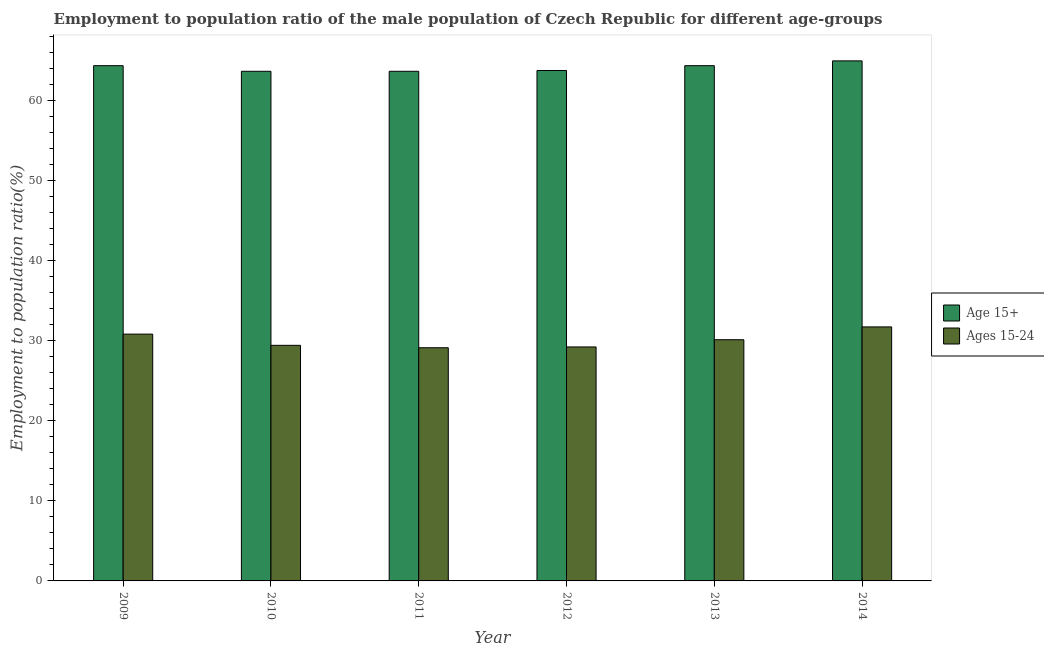How many different coloured bars are there?
Keep it short and to the point. 2. How many groups of bars are there?
Keep it short and to the point. 6. Are the number of bars per tick equal to the number of legend labels?
Ensure brevity in your answer.  Yes. How many bars are there on the 6th tick from the left?
Ensure brevity in your answer.  2. How many bars are there on the 1st tick from the right?
Provide a succinct answer. 2. In how many cases, is the number of bars for a given year not equal to the number of legend labels?
Give a very brief answer. 0. What is the employment to population ratio(age 15-24) in 2009?
Make the answer very short. 30.8. Across all years, what is the maximum employment to population ratio(age 15+)?
Your answer should be compact. 64.9. Across all years, what is the minimum employment to population ratio(age 15+)?
Your answer should be compact. 63.6. What is the total employment to population ratio(age 15-24) in the graph?
Ensure brevity in your answer.  180.3. What is the difference between the employment to population ratio(age 15-24) in 2012 and that in 2013?
Ensure brevity in your answer.  -0.9. What is the difference between the employment to population ratio(age 15-24) in 2009 and the employment to population ratio(age 15+) in 2013?
Ensure brevity in your answer.  0.7. What is the average employment to population ratio(age 15+) per year?
Your answer should be compact. 64.07. What is the ratio of the employment to population ratio(age 15-24) in 2010 to that in 2013?
Provide a succinct answer. 0.98. What is the difference between the highest and the second highest employment to population ratio(age 15-24)?
Make the answer very short. 0.9. What is the difference between the highest and the lowest employment to population ratio(age 15+)?
Your answer should be compact. 1.3. What does the 2nd bar from the left in 2014 represents?
Offer a terse response. Ages 15-24. What does the 2nd bar from the right in 2010 represents?
Provide a succinct answer. Age 15+. How many bars are there?
Keep it short and to the point. 12. Are all the bars in the graph horizontal?
Make the answer very short. No. How many years are there in the graph?
Make the answer very short. 6. Does the graph contain grids?
Make the answer very short. No. Where does the legend appear in the graph?
Give a very brief answer. Center right. How many legend labels are there?
Your answer should be compact. 2. How are the legend labels stacked?
Your response must be concise. Vertical. What is the title of the graph?
Provide a succinct answer. Employment to population ratio of the male population of Czech Republic for different age-groups. Does "Old" appear as one of the legend labels in the graph?
Provide a short and direct response. No. What is the label or title of the X-axis?
Your answer should be very brief. Year. What is the Employment to population ratio(%) of Age 15+ in 2009?
Your response must be concise. 64.3. What is the Employment to population ratio(%) of Ages 15-24 in 2009?
Make the answer very short. 30.8. What is the Employment to population ratio(%) in Age 15+ in 2010?
Your answer should be very brief. 63.6. What is the Employment to population ratio(%) of Ages 15-24 in 2010?
Provide a succinct answer. 29.4. What is the Employment to population ratio(%) of Age 15+ in 2011?
Give a very brief answer. 63.6. What is the Employment to population ratio(%) in Ages 15-24 in 2011?
Your answer should be very brief. 29.1. What is the Employment to population ratio(%) of Age 15+ in 2012?
Keep it short and to the point. 63.7. What is the Employment to population ratio(%) of Ages 15-24 in 2012?
Offer a terse response. 29.2. What is the Employment to population ratio(%) in Age 15+ in 2013?
Make the answer very short. 64.3. What is the Employment to population ratio(%) in Ages 15-24 in 2013?
Ensure brevity in your answer.  30.1. What is the Employment to population ratio(%) in Age 15+ in 2014?
Your response must be concise. 64.9. What is the Employment to population ratio(%) of Ages 15-24 in 2014?
Ensure brevity in your answer.  31.7. Across all years, what is the maximum Employment to population ratio(%) of Age 15+?
Provide a short and direct response. 64.9. Across all years, what is the maximum Employment to population ratio(%) of Ages 15-24?
Ensure brevity in your answer.  31.7. Across all years, what is the minimum Employment to population ratio(%) of Age 15+?
Ensure brevity in your answer.  63.6. Across all years, what is the minimum Employment to population ratio(%) of Ages 15-24?
Provide a short and direct response. 29.1. What is the total Employment to population ratio(%) of Age 15+ in the graph?
Offer a terse response. 384.4. What is the total Employment to population ratio(%) in Ages 15-24 in the graph?
Give a very brief answer. 180.3. What is the difference between the Employment to population ratio(%) in Age 15+ in 2009 and that in 2011?
Your answer should be very brief. 0.7. What is the difference between the Employment to population ratio(%) of Ages 15-24 in 2009 and that in 2011?
Keep it short and to the point. 1.7. What is the difference between the Employment to population ratio(%) in Age 15+ in 2009 and that in 2013?
Offer a terse response. 0. What is the difference between the Employment to population ratio(%) in Age 15+ in 2010 and that in 2011?
Give a very brief answer. 0. What is the difference between the Employment to population ratio(%) in Age 15+ in 2010 and that in 2012?
Provide a short and direct response. -0.1. What is the difference between the Employment to population ratio(%) in Ages 15-24 in 2010 and that in 2012?
Provide a short and direct response. 0.2. What is the difference between the Employment to population ratio(%) of Age 15+ in 2010 and that in 2013?
Ensure brevity in your answer.  -0.7. What is the difference between the Employment to population ratio(%) of Ages 15-24 in 2010 and that in 2013?
Make the answer very short. -0.7. What is the difference between the Employment to population ratio(%) of Age 15+ in 2011 and that in 2012?
Your answer should be very brief. -0.1. What is the difference between the Employment to population ratio(%) in Ages 15-24 in 2011 and that in 2013?
Keep it short and to the point. -1. What is the difference between the Employment to population ratio(%) in Age 15+ in 2012 and that in 2014?
Provide a short and direct response. -1.2. What is the difference between the Employment to population ratio(%) in Ages 15-24 in 2012 and that in 2014?
Keep it short and to the point. -2.5. What is the difference between the Employment to population ratio(%) in Age 15+ in 2009 and the Employment to population ratio(%) in Ages 15-24 in 2010?
Provide a short and direct response. 34.9. What is the difference between the Employment to population ratio(%) in Age 15+ in 2009 and the Employment to population ratio(%) in Ages 15-24 in 2011?
Offer a very short reply. 35.2. What is the difference between the Employment to population ratio(%) in Age 15+ in 2009 and the Employment to population ratio(%) in Ages 15-24 in 2012?
Keep it short and to the point. 35.1. What is the difference between the Employment to population ratio(%) in Age 15+ in 2009 and the Employment to population ratio(%) in Ages 15-24 in 2013?
Provide a succinct answer. 34.2. What is the difference between the Employment to population ratio(%) in Age 15+ in 2009 and the Employment to population ratio(%) in Ages 15-24 in 2014?
Give a very brief answer. 32.6. What is the difference between the Employment to population ratio(%) in Age 15+ in 2010 and the Employment to population ratio(%) in Ages 15-24 in 2011?
Give a very brief answer. 34.5. What is the difference between the Employment to population ratio(%) of Age 15+ in 2010 and the Employment to population ratio(%) of Ages 15-24 in 2012?
Offer a terse response. 34.4. What is the difference between the Employment to population ratio(%) of Age 15+ in 2010 and the Employment to population ratio(%) of Ages 15-24 in 2013?
Offer a terse response. 33.5. What is the difference between the Employment to population ratio(%) of Age 15+ in 2010 and the Employment to population ratio(%) of Ages 15-24 in 2014?
Provide a short and direct response. 31.9. What is the difference between the Employment to population ratio(%) in Age 15+ in 2011 and the Employment to population ratio(%) in Ages 15-24 in 2012?
Give a very brief answer. 34.4. What is the difference between the Employment to population ratio(%) of Age 15+ in 2011 and the Employment to population ratio(%) of Ages 15-24 in 2013?
Give a very brief answer. 33.5. What is the difference between the Employment to population ratio(%) of Age 15+ in 2011 and the Employment to population ratio(%) of Ages 15-24 in 2014?
Offer a very short reply. 31.9. What is the difference between the Employment to population ratio(%) in Age 15+ in 2012 and the Employment to population ratio(%) in Ages 15-24 in 2013?
Provide a succinct answer. 33.6. What is the difference between the Employment to population ratio(%) in Age 15+ in 2013 and the Employment to population ratio(%) in Ages 15-24 in 2014?
Offer a very short reply. 32.6. What is the average Employment to population ratio(%) in Age 15+ per year?
Make the answer very short. 64.07. What is the average Employment to population ratio(%) in Ages 15-24 per year?
Ensure brevity in your answer.  30.05. In the year 2009, what is the difference between the Employment to population ratio(%) of Age 15+ and Employment to population ratio(%) of Ages 15-24?
Give a very brief answer. 33.5. In the year 2010, what is the difference between the Employment to population ratio(%) in Age 15+ and Employment to population ratio(%) in Ages 15-24?
Keep it short and to the point. 34.2. In the year 2011, what is the difference between the Employment to population ratio(%) of Age 15+ and Employment to population ratio(%) of Ages 15-24?
Offer a terse response. 34.5. In the year 2012, what is the difference between the Employment to population ratio(%) in Age 15+ and Employment to population ratio(%) in Ages 15-24?
Your response must be concise. 34.5. In the year 2013, what is the difference between the Employment to population ratio(%) of Age 15+ and Employment to population ratio(%) of Ages 15-24?
Give a very brief answer. 34.2. In the year 2014, what is the difference between the Employment to population ratio(%) in Age 15+ and Employment to population ratio(%) in Ages 15-24?
Your response must be concise. 33.2. What is the ratio of the Employment to population ratio(%) in Ages 15-24 in 2009 to that in 2010?
Provide a succinct answer. 1.05. What is the ratio of the Employment to population ratio(%) in Ages 15-24 in 2009 to that in 2011?
Your answer should be compact. 1.06. What is the ratio of the Employment to population ratio(%) of Age 15+ in 2009 to that in 2012?
Give a very brief answer. 1.01. What is the ratio of the Employment to population ratio(%) of Ages 15-24 in 2009 to that in 2012?
Your answer should be very brief. 1.05. What is the ratio of the Employment to population ratio(%) of Ages 15-24 in 2009 to that in 2013?
Your answer should be very brief. 1.02. What is the ratio of the Employment to population ratio(%) in Age 15+ in 2009 to that in 2014?
Provide a succinct answer. 0.99. What is the ratio of the Employment to population ratio(%) in Ages 15-24 in 2009 to that in 2014?
Your answer should be compact. 0.97. What is the ratio of the Employment to population ratio(%) in Age 15+ in 2010 to that in 2011?
Make the answer very short. 1. What is the ratio of the Employment to population ratio(%) of Ages 15-24 in 2010 to that in 2011?
Ensure brevity in your answer.  1.01. What is the ratio of the Employment to population ratio(%) of Ages 15-24 in 2010 to that in 2012?
Give a very brief answer. 1.01. What is the ratio of the Employment to population ratio(%) of Age 15+ in 2010 to that in 2013?
Provide a succinct answer. 0.99. What is the ratio of the Employment to population ratio(%) in Ages 15-24 in 2010 to that in 2013?
Offer a terse response. 0.98. What is the ratio of the Employment to population ratio(%) in Age 15+ in 2010 to that in 2014?
Offer a terse response. 0.98. What is the ratio of the Employment to population ratio(%) of Ages 15-24 in 2010 to that in 2014?
Ensure brevity in your answer.  0.93. What is the ratio of the Employment to population ratio(%) in Age 15+ in 2011 to that in 2012?
Make the answer very short. 1. What is the ratio of the Employment to population ratio(%) in Ages 15-24 in 2011 to that in 2013?
Ensure brevity in your answer.  0.97. What is the ratio of the Employment to population ratio(%) of Ages 15-24 in 2011 to that in 2014?
Your answer should be compact. 0.92. What is the ratio of the Employment to population ratio(%) of Ages 15-24 in 2012 to that in 2013?
Ensure brevity in your answer.  0.97. What is the ratio of the Employment to population ratio(%) in Age 15+ in 2012 to that in 2014?
Give a very brief answer. 0.98. What is the ratio of the Employment to population ratio(%) in Ages 15-24 in 2012 to that in 2014?
Your response must be concise. 0.92. What is the ratio of the Employment to population ratio(%) of Age 15+ in 2013 to that in 2014?
Make the answer very short. 0.99. What is the ratio of the Employment to population ratio(%) in Ages 15-24 in 2013 to that in 2014?
Your answer should be compact. 0.95. What is the difference between the highest and the second highest Employment to population ratio(%) of Ages 15-24?
Give a very brief answer. 0.9. What is the difference between the highest and the lowest Employment to population ratio(%) in Ages 15-24?
Offer a terse response. 2.6. 